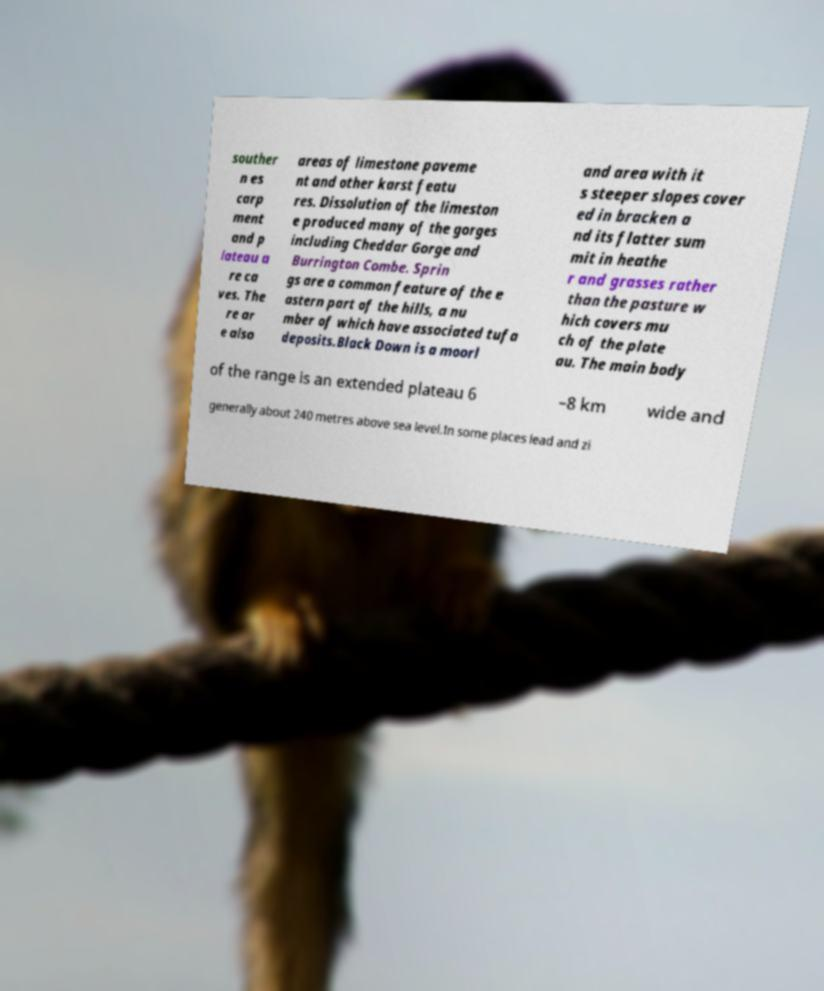Can you accurately transcribe the text from the provided image for me? souther n es carp ment and p lateau a re ca ves. The re ar e also areas of limestone paveme nt and other karst featu res. Dissolution of the limeston e produced many of the gorges including Cheddar Gorge and Burrington Combe. Sprin gs are a common feature of the e astern part of the hills, a nu mber of which have associated tufa deposits.Black Down is a moorl and area with it s steeper slopes cover ed in bracken a nd its flatter sum mit in heathe r and grasses rather than the pasture w hich covers mu ch of the plate au. The main body of the range is an extended plateau 6 –8 km wide and generally about 240 metres above sea level.In some places lead and zi 